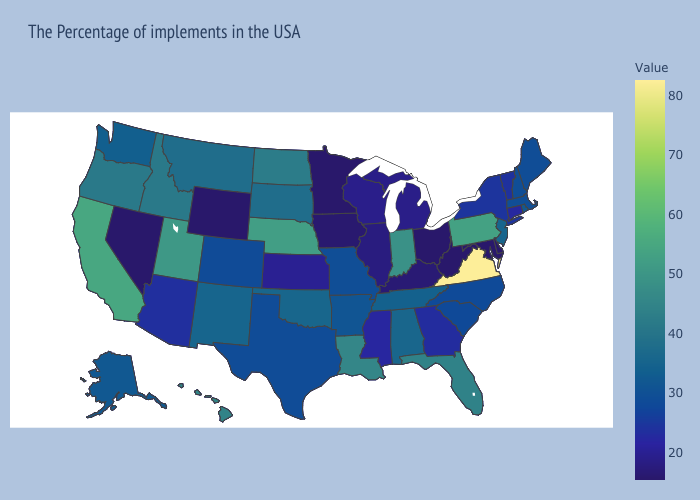Does Connecticut have a higher value than North Dakota?
Quick response, please. No. Among the states that border Nebraska , which have the lowest value?
Quick response, please. Wyoming. Among the states that border North Carolina , does Tennessee have the lowest value?
Short answer required. No. Which states have the lowest value in the South?
Answer briefly. Delaware, Maryland, West Virginia. Among the states that border North Carolina , does Virginia have the lowest value?
Give a very brief answer. No. 